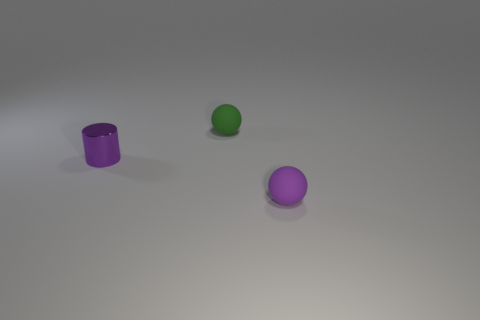There is a tiny purple metal thing; does it have the same shape as the matte object right of the small green rubber object?
Make the answer very short. No. What number of other objects are there of the same shape as the purple metallic object?
Offer a very short reply. 0. How many objects are small balls or purple shiny objects?
Your response must be concise. 3. Is there anything else that has the same size as the purple sphere?
Provide a short and direct response. Yes. What is the shape of the small purple thing that is on the left side of the tiny matte thing behind the purple matte sphere?
Make the answer very short. Cylinder. Are there fewer small purple metallic things than large yellow shiny balls?
Give a very brief answer. No. There is a thing that is both on the left side of the small purple rubber ball and right of the metallic cylinder; how big is it?
Make the answer very short. Small. Does the purple cylinder have the same size as the green rubber thing?
Make the answer very short. Yes. Is the color of the rubber thing behind the small purple ball the same as the metal object?
Your response must be concise. No. What number of objects are in front of the tiny purple cylinder?
Ensure brevity in your answer.  1. 